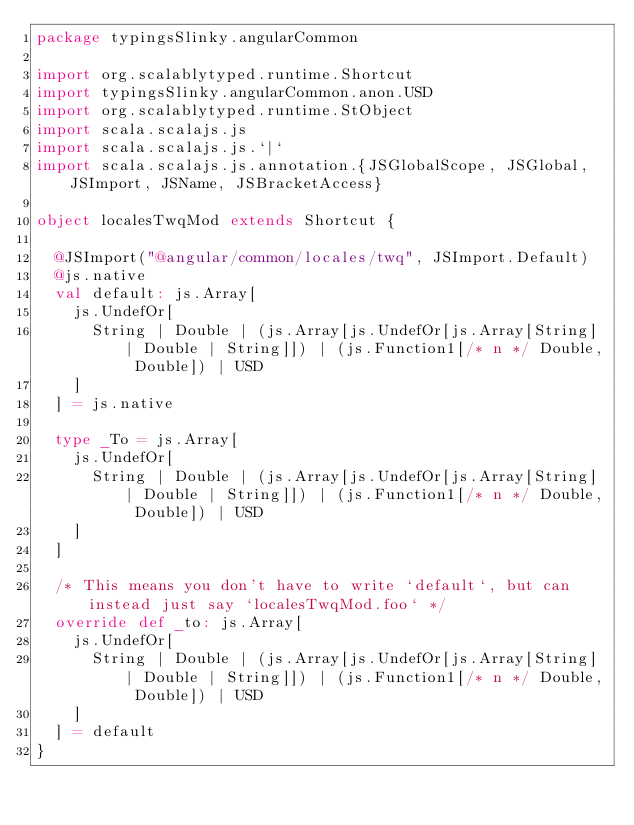Convert code to text. <code><loc_0><loc_0><loc_500><loc_500><_Scala_>package typingsSlinky.angularCommon

import org.scalablytyped.runtime.Shortcut
import typingsSlinky.angularCommon.anon.USD
import org.scalablytyped.runtime.StObject
import scala.scalajs.js
import scala.scalajs.js.`|`
import scala.scalajs.js.annotation.{JSGlobalScope, JSGlobal, JSImport, JSName, JSBracketAccess}

object localesTwqMod extends Shortcut {
  
  @JSImport("@angular/common/locales/twq", JSImport.Default)
  @js.native
  val default: js.Array[
    js.UndefOr[
      String | Double | (js.Array[js.UndefOr[js.Array[String] | Double | String]]) | (js.Function1[/* n */ Double, Double]) | USD
    ]
  ] = js.native
  
  type _To = js.Array[
    js.UndefOr[
      String | Double | (js.Array[js.UndefOr[js.Array[String] | Double | String]]) | (js.Function1[/* n */ Double, Double]) | USD
    ]
  ]
  
  /* This means you don't have to write `default`, but can instead just say `localesTwqMod.foo` */
  override def _to: js.Array[
    js.UndefOr[
      String | Double | (js.Array[js.UndefOr[js.Array[String] | Double | String]]) | (js.Function1[/* n */ Double, Double]) | USD
    ]
  ] = default
}
</code> 